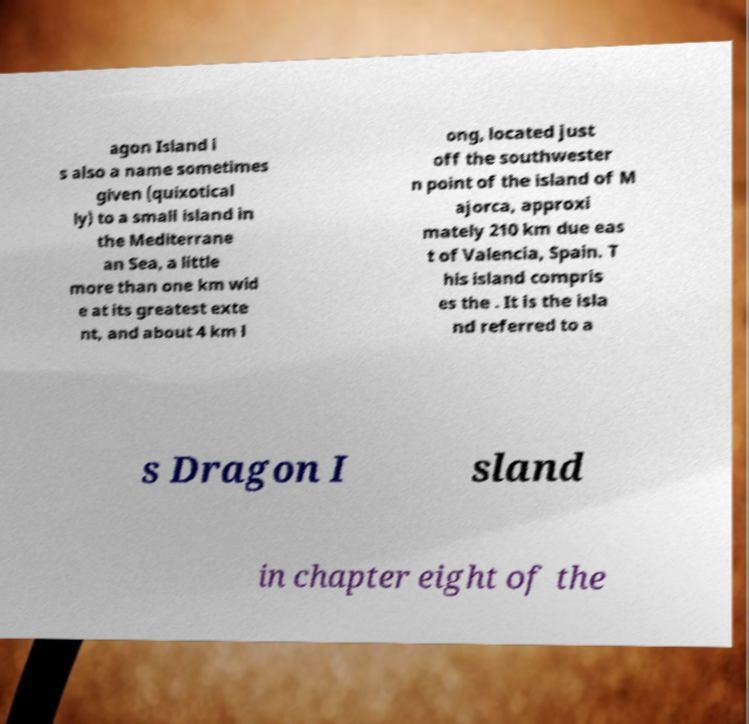Could you assist in decoding the text presented in this image and type it out clearly? agon Island i s also a name sometimes given (quixotical ly) to a small island in the Mediterrane an Sea, a little more than one km wid e at its greatest exte nt, and about 4 km l ong, located just off the southwester n point of the island of M ajorca, approxi mately 210 km due eas t of Valencia, Spain. T his island compris es the . It is the isla nd referred to a s Dragon I sland in chapter eight of the 